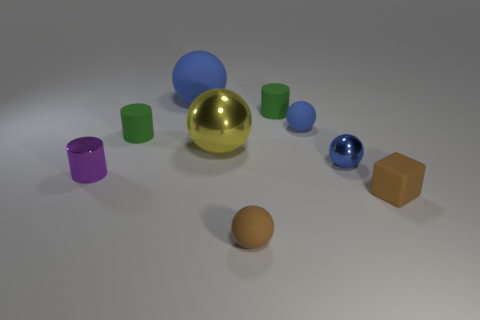What number of other tiny things have the same shape as the purple thing?
Your answer should be compact. 2. The rubber cube has what color?
Provide a succinct answer. Brown. Are there any big objects that have the same color as the tiny metal ball?
Your response must be concise. Yes. Does the small rubber sphere that is in front of the cube have the same color as the tiny matte cube?
Ensure brevity in your answer.  Yes. What number of objects are cylinders right of the small brown matte ball or small rubber cylinders?
Your answer should be very brief. 2. There is a big blue sphere; are there any large matte things behind it?
Provide a short and direct response. No. Is the tiny sphere that is in front of the tiny purple object made of the same material as the purple thing?
Provide a short and direct response. No. Are there any spheres that are on the right side of the large thing that is behind the tiny rubber sphere that is behind the small purple metallic cylinder?
Your answer should be very brief. Yes. How many cylinders are either large green shiny objects or blue matte things?
Your answer should be very brief. 0. There is a tiny cylinder in front of the small blue metallic object; what is its material?
Offer a very short reply. Metal. 